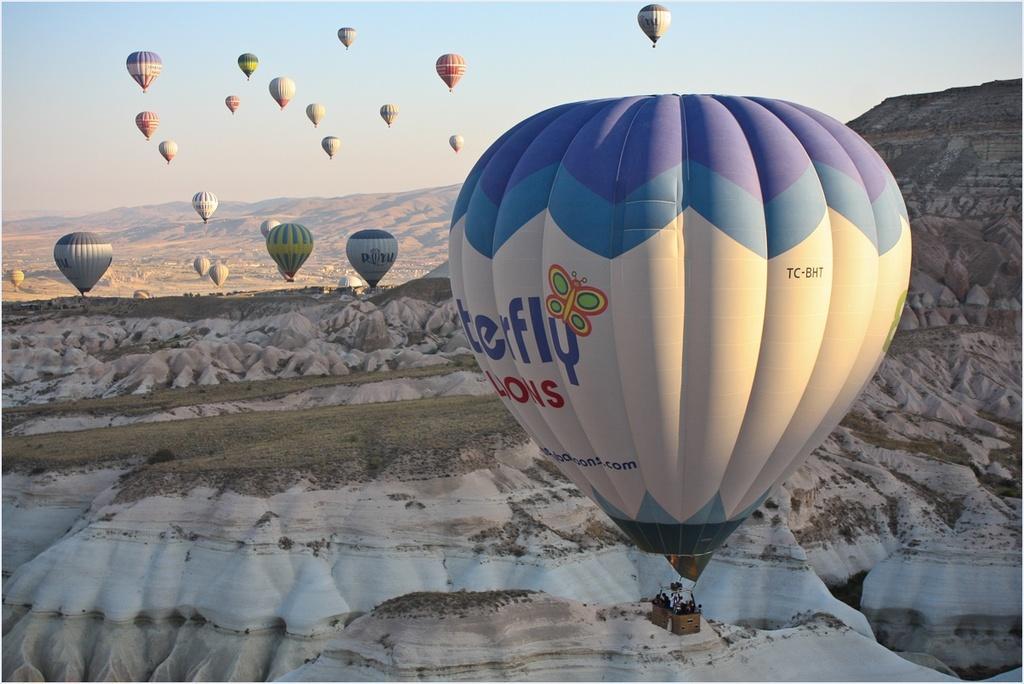Can you describe this image briefly? It seems like some people are in the parachutes and in the background, there are mountains. 